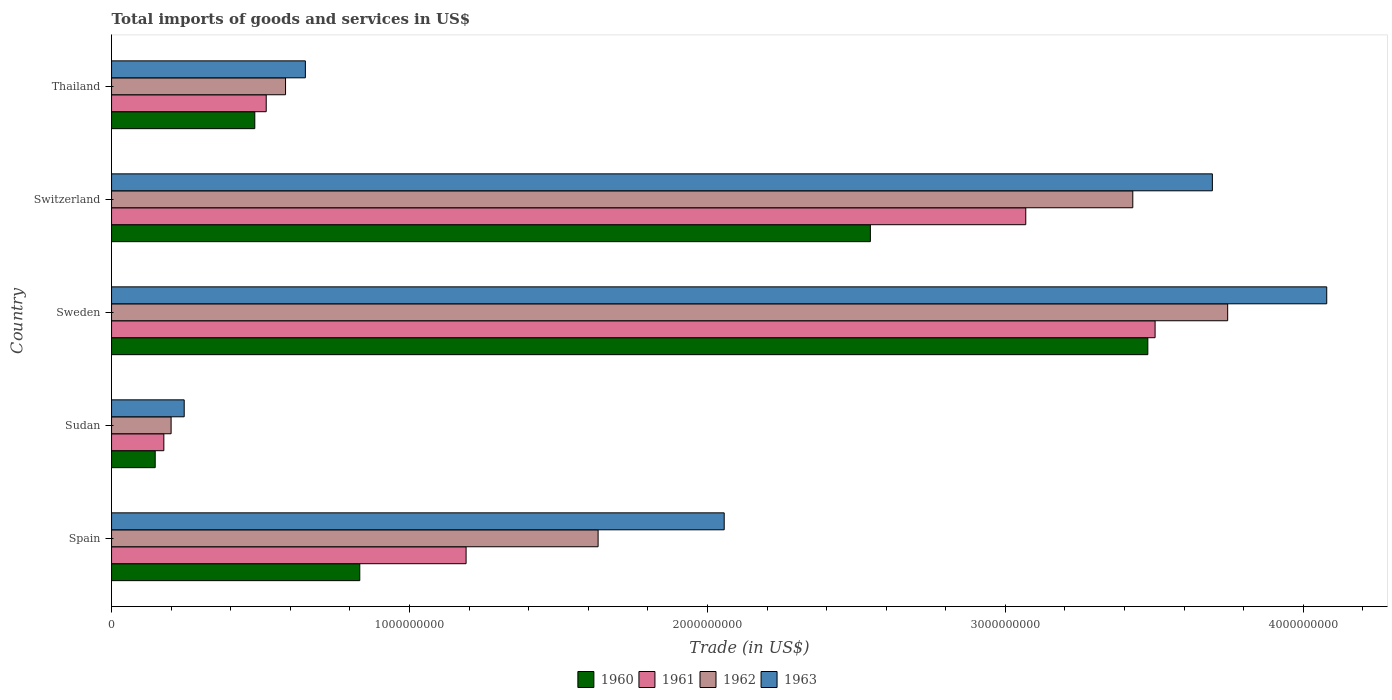Are the number of bars per tick equal to the number of legend labels?
Provide a succinct answer. Yes. Are the number of bars on each tick of the Y-axis equal?
Your answer should be very brief. Yes. How many bars are there on the 5th tick from the top?
Provide a short and direct response. 4. What is the label of the 4th group of bars from the top?
Make the answer very short. Sudan. In how many cases, is the number of bars for a given country not equal to the number of legend labels?
Your response must be concise. 0. What is the total imports of goods and services in 1961 in Spain?
Your answer should be compact. 1.19e+09. Across all countries, what is the maximum total imports of goods and services in 1961?
Your answer should be very brief. 3.50e+09. Across all countries, what is the minimum total imports of goods and services in 1963?
Provide a succinct answer. 2.44e+08. In which country was the total imports of goods and services in 1962 maximum?
Provide a short and direct response. Sweden. In which country was the total imports of goods and services in 1960 minimum?
Make the answer very short. Sudan. What is the total total imports of goods and services in 1962 in the graph?
Ensure brevity in your answer.  9.59e+09. What is the difference between the total imports of goods and services in 1960 in Spain and that in Sweden?
Your response must be concise. -2.65e+09. What is the difference between the total imports of goods and services in 1961 in Switzerland and the total imports of goods and services in 1963 in Sudan?
Offer a terse response. 2.82e+09. What is the average total imports of goods and services in 1962 per country?
Offer a very short reply. 1.92e+09. What is the difference between the total imports of goods and services in 1960 and total imports of goods and services in 1961 in Sudan?
Offer a terse response. -2.90e+07. In how many countries, is the total imports of goods and services in 1961 greater than 2400000000 US$?
Your answer should be compact. 2. What is the ratio of the total imports of goods and services in 1960 in Sudan to that in Sweden?
Offer a very short reply. 0.04. Is the total imports of goods and services in 1963 in Sweden less than that in Switzerland?
Make the answer very short. No. What is the difference between the highest and the second highest total imports of goods and services in 1961?
Your answer should be compact. 4.34e+08. What is the difference between the highest and the lowest total imports of goods and services in 1961?
Keep it short and to the point. 3.33e+09. Is the sum of the total imports of goods and services in 1960 in Spain and Sudan greater than the maximum total imports of goods and services in 1962 across all countries?
Your answer should be compact. No. Is it the case that in every country, the sum of the total imports of goods and services in 1961 and total imports of goods and services in 1962 is greater than the total imports of goods and services in 1960?
Provide a short and direct response. Yes. How many bars are there?
Your answer should be very brief. 20. What is the difference between two consecutive major ticks on the X-axis?
Offer a very short reply. 1.00e+09. Does the graph contain any zero values?
Keep it short and to the point. No. Does the graph contain grids?
Offer a terse response. No. How are the legend labels stacked?
Your answer should be very brief. Horizontal. What is the title of the graph?
Keep it short and to the point. Total imports of goods and services in US$. What is the label or title of the X-axis?
Keep it short and to the point. Trade (in US$). What is the label or title of the Y-axis?
Provide a succinct answer. Country. What is the Trade (in US$) in 1960 in Spain?
Your answer should be compact. 8.33e+08. What is the Trade (in US$) of 1961 in Spain?
Provide a short and direct response. 1.19e+09. What is the Trade (in US$) in 1962 in Spain?
Keep it short and to the point. 1.63e+09. What is the Trade (in US$) in 1963 in Spain?
Keep it short and to the point. 2.06e+09. What is the Trade (in US$) in 1960 in Sudan?
Keep it short and to the point. 1.46e+08. What is the Trade (in US$) of 1961 in Sudan?
Keep it short and to the point. 1.75e+08. What is the Trade (in US$) in 1962 in Sudan?
Give a very brief answer. 2.00e+08. What is the Trade (in US$) of 1963 in Sudan?
Keep it short and to the point. 2.44e+08. What is the Trade (in US$) in 1960 in Sweden?
Give a very brief answer. 3.48e+09. What is the Trade (in US$) in 1961 in Sweden?
Offer a very short reply. 3.50e+09. What is the Trade (in US$) in 1962 in Sweden?
Make the answer very short. 3.75e+09. What is the Trade (in US$) in 1963 in Sweden?
Offer a terse response. 4.08e+09. What is the Trade (in US$) of 1960 in Switzerland?
Offer a very short reply. 2.55e+09. What is the Trade (in US$) in 1961 in Switzerland?
Provide a short and direct response. 3.07e+09. What is the Trade (in US$) in 1962 in Switzerland?
Your answer should be very brief. 3.43e+09. What is the Trade (in US$) in 1963 in Switzerland?
Provide a succinct answer. 3.69e+09. What is the Trade (in US$) in 1960 in Thailand?
Your answer should be very brief. 4.81e+08. What is the Trade (in US$) of 1961 in Thailand?
Offer a terse response. 5.19e+08. What is the Trade (in US$) of 1962 in Thailand?
Provide a succinct answer. 5.84e+08. What is the Trade (in US$) in 1963 in Thailand?
Your answer should be compact. 6.51e+08. Across all countries, what is the maximum Trade (in US$) in 1960?
Ensure brevity in your answer.  3.48e+09. Across all countries, what is the maximum Trade (in US$) in 1961?
Provide a short and direct response. 3.50e+09. Across all countries, what is the maximum Trade (in US$) in 1962?
Offer a very short reply. 3.75e+09. Across all countries, what is the maximum Trade (in US$) of 1963?
Offer a terse response. 4.08e+09. Across all countries, what is the minimum Trade (in US$) of 1960?
Ensure brevity in your answer.  1.46e+08. Across all countries, what is the minimum Trade (in US$) in 1961?
Your response must be concise. 1.75e+08. Across all countries, what is the minimum Trade (in US$) in 1962?
Give a very brief answer. 2.00e+08. Across all countries, what is the minimum Trade (in US$) in 1963?
Offer a very short reply. 2.44e+08. What is the total Trade (in US$) in 1960 in the graph?
Provide a short and direct response. 7.49e+09. What is the total Trade (in US$) in 1961 in the graph?
Your answer should be compact. 8.46e+09. What is the total Trade (in US$) of 1962 in the graph?
Make the answer very short. 9.59e+09. What is the total Trade (in US$) in 1963 in the graph?
Give a very brief answer. 1.07e+1. What is the difference between the Trade (in US$) of 1960 in Spain and that in Sudan?
Make the answer very short. 6.87e+08. What is the difference between the Trade (in US$) of 1961 in Spain and that in Sudan?
Make the answer very short. 1.01e+09. What is the difference between the Trade (in US$) in 1962 in Spain and that in Sudan?
Your response must be concise. 1.43e+09. What is the difference between the Trade (in US$) of 1963 in Spain and that in Sudan?
Offer a terse response. 1.81e+09. What is the difference between the Trade (in US$) of 1960 in Spain and that in Sweden?
Your response must be concise. -2.65e+09. What is the difference between the Trade (in US$) of 1961 in Spain and that in Sweden?
Ensure brevity in your answer.  -2.31e+09. What is the difference between the Trade (in US$) of 1962 in Spain and that in Sweden?
Provide a short and direct response. -2.11e+09. What is the difference between the Trade (in US$) of 1963 in Spain and that in Sweden?
Provide a short and direct response. -2.02e+09. What is the difference between the Trade (in US$) of 1960 in Spain and that in Switzerland?
Your response must be concise. -1.71e+09. What is the difference between the Trade (in US$) in 1961 in Spain and that in Switzerland?
Your answer should be very brief. -1.88e+09. What is the difference between the Trade (in US$) of 1962 in Spain and that in Switzerland?
Your response must be concise. -1.79e+09. What is the difference between the Trade (in US$) of 1963 in Spain and that in Switzerland?
Keep it short and to the point. -1.64e+09. What is the difference between the Trade (in US$) of 1960 in Spain and that in Thailand?
Give a very brief answer. 3.52e+08. What is the difference between the Trade (in US$) of 1961 in Spain and that in Thailand?
Offer a very short reply. 6.71e+08. What is the difference between the Trade (in US$) in 1962 in Spain and that in Thailand?
Make the answer very short. 1.05e+09. What is the difference between the Trade (in US$) in 1963 in Spain and that in Thailand?
Provide a succinct answer. 1.41e+09. What is the difference between the Trade (in US$) of 1960 in Sudan and that in Sweden?
Ensure brevity in your answer.  -3.33e+09. What is the difference between the Trade (in US$) in 1961 in Sudan and that in Sweden?
Ensure brevity in your answer.  -3.33e+09. What is the difference between the Trade (in US$) in 1962 in Sudan and that in Sweden?
Your answer should be very brief. -3.55e+09. What is the difference between the Trade (in US$) in 1963 in Sudan and that in Sweden?
Ensure brevity in your answer.  -3.83e+09. What is the difference between the Trade (in US$) of 1960 in Sudan and that in Switzerland?
Provide a succinct answer. -2.40e+09. What is the difference between the Trade (in US$) of 1961 in Sudan and that in Switzerland?
Your response must be concise. -2.89e+09. What is the difference between the Trade (in US$) in 1962 in Sudan and that in Switzerland?
Your answer should be very brief. -3.23e+09. What is the difference between the Trade (in US$) of 1963 in Sudan and that in Switzerland?
Your answer should be very brief. -3.45e+09. What is the difference between the Trade (in US$) of 1960 in Sudan and that in Thailand?
Provide a short and direct response. -3.34e+08. What is the difference between the Trade (in US$) in 1961 in Sudan and that in Thailand?
Keep it short and to the point. -3.44e+08. What is the difference between the Trade (in US$) in 1962 in Sudan and that in Thailand?
Your answer should be very brief. -3.84e+08. What is the difference between the Trade (in US$) of 1963 in Sudan and that in Thailand?
Ensure brevity in your answer.  -4.07e+08. What is the difference between the Trade (in US$) of 1960 in Sweden and that in Switzerland?
Offer a very short reply. 9.31e+08. What is the difference between the Trade (in US$) in 1961 in Sweden and that in Switzerland?
Offer a very short reply. 4.34e+08. What is the difference between the Trade (in US$) in 1962 in Sweden and that in Switzerland?
Your answer should be very brief. 3.18e+08. What is the difference between the Trade (in US$) in 1963 in Sweden and that in Switzerland?
Provide a succinct answer. 3.84e+08. What is the difference between the Trade (in US$) of 1960 in Sweden and that in Thailand?
Offer a very short reply. 3.00e+09. What is the difference between the Trade (in US$) in 1961 in Sweden and that in Thailand?
Ensure brevity in your answer.  2.98e+09. What is the difference between the Trade (in US$) of 1962 in Sweden and that in Thailand?
Provide a short and direct response. 3.16e+09. What is the difference between the Trade (in US$) in 1963 in Sweden and that in Thailand?
Keep it short and to the point. 3.43e+09. What is the difference between the Trade (in US$) in 1960 in Switzerland and that in Thailand?
Provide a short and direct response. 2.07e+09. What is the difference between the Trade (in US$) of 1961 in Switzerland and that in Thailand?
Your answer should be very brief. 2.55e+09. What is the difference between the Trade (in US$) in 1962 in Switzerland and that in Thailand?
Ensure brevity in your answer.  2.84e+09. What is the difference between the Trade (in US$) in 1963 in Switzerland and that in Thailand?
Ensure brevity in your answer.  3.04e+09. What is the difference between the Trade (in US$) of 1960 in Spain and the Trade (in US$) of 1961 in Sudan?
Your answer should be compact. 6.58e+08. What is the difference between the Trade (in US$) in 1960 in Spain and the Trade (in US$) in 1962 in Sudan?
Your answer should be very brief. 6.33e+08. What is the difference between the Trade (in US$) of 1960 in Spain and the Trade (in US$) of 1963 in Sudan?
Your answer should be compact. 5.89e+08. What is the difference between the Trade (in US$) of 1961 in Spain and the Trade (in US$) of 1962 in Sudan?
Give a very brief answer. 9.90e+08. What is the difference between the Trade (in US$) of 1961 in Spain and the Trade (in US$) of 1963 in Sudan?
Keep it short and to the point. 9.46e+08. What is the difference between the Trade (in US$) in 1962 in Spain and the Trade (in US$) in 1963 in Sudan?
Provide a short and direct response. 1.39e+09. What is the difference between the Trade (in US$) of 1960 in Spain and the Trade (in US$) of 1961 in Sweden?
Your answer should be very brief. -2.67e+09. What is the difference between the Trade (in US$) in 1960 in Spain and the Trade (in US$) in 1962 in Sweden?
Keep it short and to the point. -2.91e+09. What is the difference between the Trade (in US$) in 1960 in Spain and the Trade (in US$) in 1963 in Sweden?
Your response must be concise. -3.25e+09. What is the difference between the Trade (in US$) in 1961 in Spain and the Trade (in US$) in 1962 in Sweden?
Your answer should be very brief. -2.56e+09. What is the difference between the Trade (in US$) of 1961 in Spain and the Trade (in US$) of 1963 in Sweden?
Keep it short and to the point. -2.89e+09. What is the difference between the Trade (in US$) in 1962 in Spain and the Trade (in US$) in 1963 in Sweden?
Your response must be concise. -2.45e+09. What is the difference between the Trade (in US$) of 1960 in Spain and the Trade (in US$) of 1961 in Switzerland?
Offer a very short reply. -2.24e+09. What is the difference between the Trade (in US$) of 1960 in Spain and the Trade (in US$) of 1962 in Switzerland?
Provide a succinct answer. -2.59e+09. What is the difference between the Trade (in US$) in 1960 in Spain and the Trade (in US$) in 1963 in Switzerland?
Your answer should be compact. -2.86e+09. What is the difference between the Trade (in US$) in 1961 in Spain and the Trade (in US$) in 1962 in Switzerland?
Offer a terse response. -2.24e+09. What is the difference between the Trade (in US$) of 1961 in Spain and the Trade (in US$) of 1963 in Switzerland?
Give a very brief answer. -2.50e+09. What is the difference between the Trade (in US$) in 1962 in Spain and the Trade (in US$) in 1963 in Switzerland?
Ensure brevity in your answer.  -2.06e+09. What is the difference between the Trade (in US$) of 1960 in Spain and the Trade (in US$) of 1961 in Thailand?
Keep it short and to the point. 3.14e+08. What is the difference between the Trade (in US$) in 1960 in Spain and the Trade (in US$) in 1962 in Thailand?
Make the answer very short. 2.49e+08. What is the difference between the Trade (in US$) of 1960 in Spain and the Trade (in US$) of 1963 in Thailand?
Offer a very short reply. 1.83e+08. What is the difference between the Trade (in US$) in 1961 in Spain and the Trade (in US$) in 1962 in Thailand?
Keep it short and to the point. 6.06e+08. What is the difference between the Trade (in US$) in 1961 in Spain and the Trade (in US$) in 1963 in Thailand?
Offer a very short reply. 5.39e+08. What is the difference between the Trade (in US$) in 1962 in Spain and the Trade (in US$) in 1963 in Thailand?
Give a very brief answer. 9.83e+08. What is the difference between the Trade (in US$) in 1960 in Sudan and the Trade (in US$) in 1961 in Sweden?
Give a very brief answer. -3.36e+09. What is the difference between the Trade (in US$) in 1960 in Sudan and the Trade (in US$) in 1962 in Sweden?
Provide a short and direct response. -3.60e+09. What is the difference between the Trade (in US$) in 1960 in Sudan and the Trade (in US$) in 1963 in Sweden?
Provide a short and direct response. -3.93e+09. What is the difference between the Trade (in US$) of 1961 in Sudan and the Trade (in US$) of 1962 in Sweden?
Provide a short and direct response. -3.57e+09. What is the difference between the Trade (in US$) in 1961 in Sudan and the Trade (in US$) in 1963 in Sweden?
Provide a succinct answer. -3.90e+09. What is the difference between the Trade (in US$) in 1962 in Sudan and the Trade (in US$) in 1963 in Sweden?
Provide a succinct answer. -3.88e+09. What is the difference between the Trade (in US$) in 1960 in Sudan and the Trade (in US$) in 1961 in Switzerland?
Your answer should be compact. -2.92e+09. What is the difference between the Trade (in US$) in 1960 in Sudan and the Trade (in US$) in 1962 in Switzerland?
Your answer should be compact. -3.28e+09. What is the difference between the Trade (in US$) in 1960 in Sudan and the Trade (in US$) in 1963 in Switzerland?
Provide a short and direct response. -3.55e+09. What is the difference between the Trade (in US$) of 1961 in Sudan and the Trade (in US$) of 1962 in Switzerland?
Ensure brevity in your answer.  -3.25e+09. What is the difference between the Trade (in US$) in 1961 in Sudan and the Trade (in US$) in 1963 in Switzerland?
Provide a succinct answer. -3.52e+09. What is the difference between the Trade (in US$) in 1962 in Sudan and the Trade (in US$) in 1963 in Switzerland?
Offer a terse response. -3.49e+09. What is the difference between the Trade (in US$) in 1960 in Sudan and the Trade (in US$) in 1961 in Thailand?
Your answer should be very brief. -3.73e+08. What is the difference between the Trade (in US$) in 1960 in Sudan and the Trade (in US$) in 1962 in Thailand?
Your answer should be compact. -4.38e+08. What is the difference between the Trade (in US$) in 1960 in Sudan and the Trade (in US$) in 1963 in Thailand?
Your response must be concise. -5.04e+08. What is the difference between the Trade (in US$) in 1961 in Sudan and the Trade (in US$) in 1962 in Thailand?
Give a very brief answer. -4.09e+08. What is the difference between the Trade (in US$) of 1961 in Sudan and the Trade (in US$) of 1963 in Thailand?
Your response must be concise. -4.75e+08. What is the difference between the Trade (in US$) of 1962 in Sudan and the Trade (in US$) of 1963 in Thailand?
Offer a terse response. -4.51e+08. What is the difference between the Trade (in US$) in 1960 in Sweden and the Trade (in US$) in 1961 in Switzerland?
Your response must be concise. 4.10e+08. What is the difference between the Trade (in US$) of 1960 in Sweden and the Trade (in US$) of 1962 in Switzerland?
Provide a succinct answer. 5.05e+07. What is the difference between the Trade (in US$) of 1960 in Sweden and the Trade (in US$) of 1963 in Switzerland?
Offer a very short reply. -2.17e+08. What is the difference between the Trade (in US$) in 1961 in Sweden and the Trade (in US$) in 1962 in Switzerland?
Your answer should be very brief. 7.48e+07. What is the difference between the Trade (in US$) of 1961 in Sweden and the Trade (in US$) of 1963 in Switzerland?
Make the answer very short. -1.92e+08. What is the difference between the Trade (in US$) in 1962 in Sweden and the Trade (in US$) in 1963 in Switzerland?
Provide a succinct answer. 5.13e+07. What is the difference between the Trade (in US$) of 1960 in Sweden and the Trade (in US$) of 1961 in Thailand?
Give a very brief answer. 2.96e+09. What is the difference between the Trade (in US$) of 1960 in Sweden and the Trade (in US$) of 1962 in Thailand?
Give a very brief answer. 2.89e+09. What is the difference between the Trade (in US$) in 1960 in Sweden and the Trade (in US$) in 1963 in Thailand?
Ensure brevity in your answer.  2.83e+09. What is the difference between the Trade (in US$) in 1961 in Sweden and the Trade (in US$) in 1962 in Thailand?
Provide a succinct answer. 2.92e+09. What is the difference between the Trade (in US$) of 1961 in Sweden and the Trade (in US$) of 1963 in Thailand?
Offer a very short reply. 2.85e+09. What is the difference between the Trade (in US$) in 1962 in Sweden and the Trade (in US$) in 1963 in Thailand?
Keep it short and to the point. 3.10e+09. What is the difference between the Trade (in US$) in 1960 in Switzerland and the Trade (in US$) in 1961 in Thailand?
Your response must be concise. 2.03e+09. What is the difference between the Trade (in US$) of 1960 in Switzerland and the Trade (in US$) of 1962 in Thailand?
Give a very brief answer. 1.96e+09. What is the difference between the Trade (in US$) of 1960 in Switzerland and the Trade (in US$) of 1963 in Thailand?
Provide a succinct answer. 1.90e+09. What is the difference between the Trade (in US$) in 1961 in Switzerland and the Trade (in US$) in 1962 in Thailand?
Your answer should be compact. 2.48e+09. What is the difference between the Trade (in US$) of 1961 in Switzerland and the Trade (in US$) of 1963 in Thailand?
Provide a succinct answer. 2.42e+09. What is the difference between the Trade (in US$) in 1962 in Switzerland and the Trade (in US$) in 1963 in Thailand?
Keep it short and to the point. 2.78e+09. What is the average Trade (in US$) of 1960 per country?
Offer a very short reply. 1.50e+09. What is the average Trade (in US$) in 1961 per country?
Your answer should be compact. 1.69e+09. What is the average Trade (in US$) in 1962 per country?
Make the answer very short. 1.92e+09. What is the average Trade (in US$) of 1963 per country?
Your answer should be compact. 2.14e+09. What is the difference between the Trade (in US$) in 1960 and Trade (in US$) in 1961 in Spain?
Give a very brief answer. -3.57e+08. What is the difference between the Trade (in US$) of 1960 and Trade (in US$) of 1962 in Spain?
Your response must be concise. -8.00e+08. What is the difference between the Trade (in US$) in 1960 and Trade (in US$) in 1963 in Spain?
Provide a succinct answer. -1.22e+09. What is the difference between the Trade (in US$) in 1961 and Trade (in US$) in 1962 in Spain?
Ensure brevity in your answer.  -4.43e+08. What is the difference between the Trade (in US$) of 1961 and Trade (in US$) of 1963 in Spain?
Your answer should be compact. -8.66e+08. What is the difference between the Trade (in US$) of 1962 and Trade (in US$) of 1963 in Spain?
Your response must be concise. -4.23e+08. What is the difference between the Trade (in US$) of 1960 and Trade (in US$) of 1961 in Sudan?
Offer a very short reply. -2.90e+07. What is the difference between the Trade (in US$) of 1960 and Trade (in US$) of 1962 in Sudan?
Provide a succinct answer. -5.34e+07. What is the difference between the Trade (in US$) in 1960 and Trade (in US$) in 1963 in Sudan?
Give a very brief answer. -9.74e+07. What is the difference between the Trade (in US$) in 1961 and Trade (in US$) in 1962 in Sudan?
Offer a terse response. -2.44e+07. What is the difference between the Trade (in US$) of 1961 and Trade (in US$) of 1963 in Sudan?
Provide a short and direct response. -6.84e+07. What is the difference between the Trade (in US$) of 1962 and Trade (in US$) of 1963 in Sudan?
Offer a terse response. -4.39e+07. What is the difference between the Trade (in US$) in 1960 and Trade (in US$) in 1961 in Sweden?
Ensure brevity in your answer.  -2.44e+07. What is the difference between the Trade (in US$) in 1960 and Trade (in US$) in 1962 in Sweden?
Keep it short and to the point. -2.68e+08. What is the difference between the Trade (in US$) in 1960 and Trade (in US$) in 1963 in Sweden?
Offer a very short reply. -6.00e+08. What is the difference between the Trade (in US$) in 1961 and Trade (in US$) in 1962 in Sweden?
Provide a short and direct response. -2.44e+08. What is the difference between the Trade (in US$) in 1961 and Trade (in US$) in 1963 in Sweden?
Offer a very short reply. -5.76e+08. What is the difference between the Trade (in US$) of 1962 and Trade (in US$) of 1963 in Sweden?
Your answer should be compact. -3.33e+08. What is the difference between the Trade (in US$) in 1960 and Trade (in US$) in 1961 in Switzerland?
Offer a terse response. -5.22e+08. What is the difference between the Trade (in US$) in 1960 and Trade (in US$) in 1962 in Switzerland?
Your answer should be very brief. -8.81e+08. What is the difference between the Trade (in US$) of 1960 and Trade (in US$) of 1963 in Switzerland?
Your answer should be very brief. -1.15e+09. What is the difference between the Trade (in US$) of 1961 and Trade (in US$) of 1962 in Switzerland?
Your response must be concise. -3.59e+08. What is the difference between the Trade (in US$) of 1961 and Trade (in US$) of 1963 in Switzerland?
Offer a very short reply. -6.26e+08. What is the difference between the Trade (in US$) of 1962 and Trade (in US$) of 1963 in Switzerland?
Offer a terse response. -2.67e+08. What is the difference between the Trade (in US$) of 1960 and Trade (in US$) of 1961 in Thailand?
Ensure brevity in your answer.  -3.83e+07. What is the difference between the Trade (in US$) of 1960 and Trade (in US$) of 1962 in Thailand?
Provide a short and direct response. -1.03e+08. What is the difference between the Trade (in US$) of 1960 and Trade (in US$) of 1963 in Thailand?
Keep it short and to the point. -1.70e+08. What is the difference between the Trade (in US$) of 1961 and Trade (in US$) of 1962 in Thailand?
Offer a terse response. -6.49e+07. What is the difference between the Trade (in US$) in 1961 and Trade (in US$) in 1963 in Thailand?
Give a very brief answer. -1.31e+08. What is the difference between the Trade (in US$) of 1962 and Trade (in US$) of 1963 in Thailand?
Your answer should be compact. -6.65e+07. What is the ratio of the Trade (in US$) of 1960 in Spain to that in Sudan?
Give a very brief answer. 5.69. What is the ratio of the Trade (in US$) of 1961 in Spain to that in Sudan?
Provide a succinct answer. 6.78. What is the ratio of the Trade (in US$) in 1962 in Spain to that in Sudan?
Keep it short and to the point. 8.17. What is the ratio of the Trade (in US$) of 1963 in Spain to that in Sudan?
Keep it short and to the point. 8.43. What is the ratio of the Trade (in US$) in 1960 in Spain to that in Sweden?
Keep it short and to the point. 0.24. What is the ratio of the Trade (in US$) of 1961 in Spain to that in Sweden?
Offer a very short reply. 0.34. What is the ratio of the Trade (in US$) in 1962 in Spain to that in Sweden?
Offer a very short reply. 0.44. What is the ratio of the Trade (in US$) of 1963 in Spain to that in Sweden?
Give a very brief answer. 0.5. What is the ratio of the Trade (in US$) of 1960 in Spain to that in Switzerland?
Provide a short and direct response. 0.33. What is the ratio of the Trade (in US$) in 1961 in Spain to that in Switzerland?
Offer a terse response. 0.39. What is the ratio of the Trade (in US$) of 1962 in Spain to that in Switzerland?
Make the answer very short. 0.48. What is the ratio of the Trade (in US$) of 1963 in Spain to that in Switzerland?
Make the answer very short. 0.56. What is the ratio of the Trade (in US$) in 1960 in Spain to that in Thailand?
Your answer should be very brief. 1.73. What is the ratio of the Trade (in US$) in 1961 in Spain to that in Thailand?
Your answer should be compact. 2.29. What is the ratio of the Trade (in US$) of 1962 in Spain to that in Thailand?
Offer a very short reply. 2.8. What is the ratio of the Trade (in US$) in 1963 in Spain to that in Thailand?
Ensure brevity in your answer.  3.16. What is the ratio of the Trade (in US$) in 1960 in Sudan to that in Sweden?
Offer a very short reply. 0.04. What is the ratio of the Trade (in US$) of 1961 in Sudan to that in Sweden?
Ensure brevity in your answer.  0.05. What is the ratio of the Trade (in US$) of 1962 in Sudan to that in Sweden?
Offer a very short reply. 0.05. What is the ratio of the Trade (in US$) of 1963 in Sudan to that in Sweden?
Your response must be concise. 0.06. What is the ratio of the Trade (in US$) of 1960 in Sudan to that in Switzerland?
Offer a very short reply. 0.06. What is the ratio of the Trade (in US$) in 1961 in Sudan to that in Switzerland?
Give a very brief answer. 0.06. What is the ratio of the Trade (in US$) of 1962 in Sudan to that in Switzerland?
Your answer should be compact. 0.06. What is the ratio of the Trade (in US$) in 1963 in Sudan to that in Switzerland?
Provide a short and direct response. 0.07. What is the ratio of the Trade (in US$) of 1960 in Sudan to that in Thailand?
Your response must be concise. 0.3. What is the ratio of the Trade (in US$) in 1961 in Sudan to that in Thailand?
Ensure brevity in your answer.  0.34. What is the ratio of the Trade (in US$) of 1962 in Sudan to that in Thailand?
Your answer should be very brief. 0.34. What is the ratio of the Trade (in US$) in 1963 in Sudan to that in Thailand?
Give a very brief answer. 0.37. What is the ratio of the Trade (in US$) of 1960 in Sweden to that in Switzerland?
Your answer should be compact. 1.37. What is the ratio of the Trade (in US$) of 1961 in Sweden to that in Switzerland?
Keep it short and to the point. 1.14. What is the ratio of the Trade (in US$) in 1962 in Sweden to that in Switzerland?
Make the answer very short. 1.09. What is the ratio of the Trade (in US$) of 1963 in Sweden to that in Switzerland?
Your answer should be very brief. 1.1. What is the ratio of the Trade (in US$) of 1960 in Sweden to that in Thailand?
Your answer should be very brief. 7.23. What is the ratio of the Trade (in US$) of 1961 in Sweden to that in Thailand?
Provide a succinct answer. 6.75. What is the ratio of the Trade (in US$) of 1962 in Sweden to that in Thailand?
Your answer should be compact. 6.41. What is the ratio of the Trade (in US$) in 1963 in Sweden to that in Thailand?
Make the answer very short. 6.27. What is the ratio of the Trade (in US$) of 1960 in Switzerland to that in Thailand?
Make the answer very short. 5.3. What is the ratio of the Trade (in US$) of 1961 in Switzerland to that in Thailand?
Provide a short and direct response. 5.91. What is the ratio of the Trade (in US$) in 1962 in Switzerland to that in Thailand?
Your response must be concise. 5.87. What is the ratio of the Trade (in US$) in 1963 in Switzerland to that in Thailand?
Offer a very short reply. 5.68. What is the difference between the highest and the second highest Trade (in US$) in 1960?
Give a very brief answer. 9.31e+08. What is the difference between the highest and the second highest Trade (in US$) in 1961?
Give a very brief answer. 4.34e+08. What is the difference between the highest and the second highest Trade (in US$) in 1962?
Offer a very short reply. 3.18e+08. What is the difference between the highest and the second highest Trade (in US$) of 1963?
Offer a very short reply. 3.84e+08. What is the difference between the highest and the lowest Trade (in US$) in 1960?
Your answer should be very brief. 3.33e+09. What is the difference between the highest and the lowest Trade (in US$) in 1961?
Ensure brevity in your answer.  3.33e+09. What is the difference between the highest and the lowest Trade (in US$) in 1962?
Your answer should be compact. 3.55e+09. What is the difference between the highest and the lowest Trade (in US$) of 1963?
Offer a terse response. 3.83e+09. 